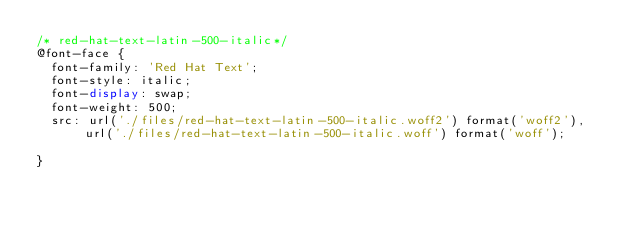<code> <loc_0><loc_0><loc_500><loc_500><_CSS_>/* red-hat-text-latin-500-italic*/
@font-face {
  font-family: 'Red Hat Text';
  font-style: italic;
  font-display: swap;
  font-weight: 500;
  src: url('./files/red-hat-text-latin-500-italic.woff2') format('woff2'), url('./files/red-hat-text-latin-500-italic.woff') format('woff');
  
}
</code> 